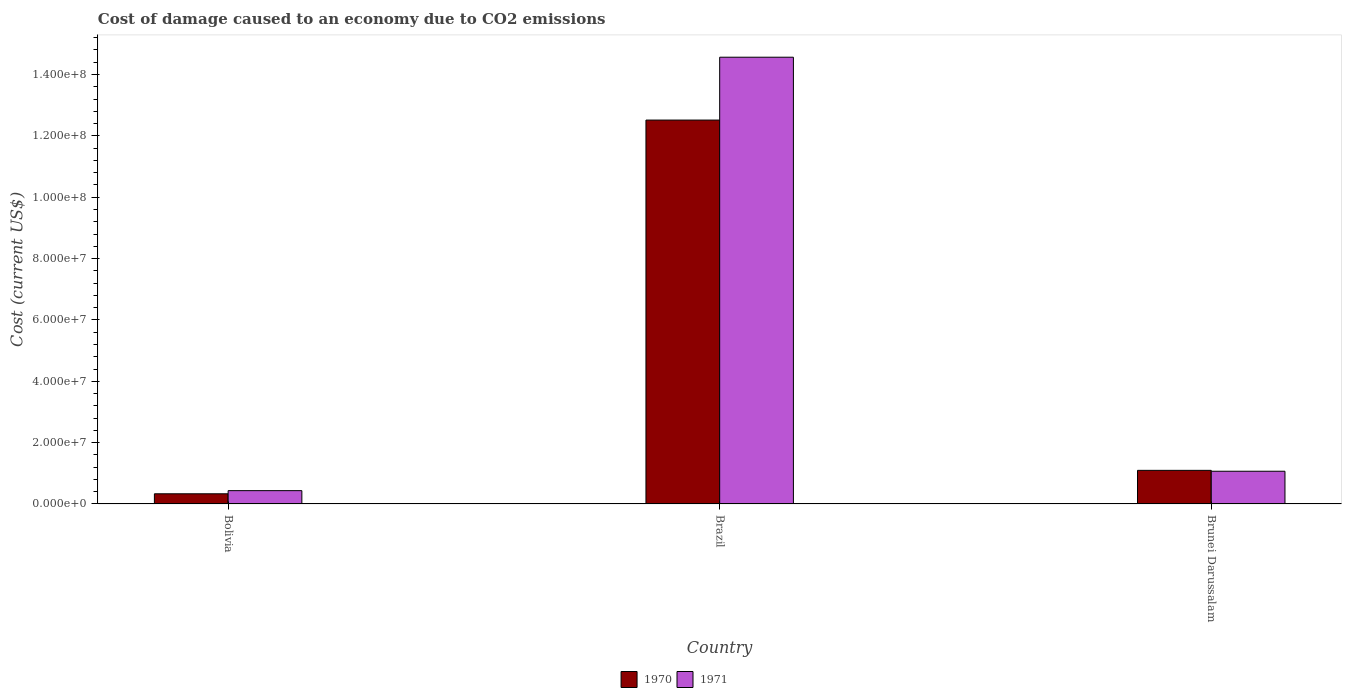Are the number of bars per tick equal to the number of legend labels?
Provide a short and direct response. Yes. How many bars are there on the 2nd tick from the left?
Give a very brief answer. 2. What is the label of the 3rd group of bars from the left?
Your answer should be compact. Brunei Darussalam. In how many cases, is the number of bars for a given country not equal to the number of legend labels?
Your answer should be very brief. 0. What is the cost of damage caused due to CO2 emissisons in 1971 in Brunei Darussalam?
Keep it short and to the point. 1.07e+07. Across all countries, what is the maximum cost of damage caused due to CO2 emissisons in 1971?
Provide a succinct answer. 1.46e+08. Across all countries, what is the minimum cost of damage caused due to CO2 emissisons in 1970?
Your response must be concise. 3.32e+06. In which country was the cost of damage caused due to CO2 emissisons in 1971 maximum?
Offer a very short reply. Brazil. In which country was the cost of damage caused due to CO2 emissisons in 1970 minimum?
Offer a terse response. Bolivia. What is the total cost of damage caused due to CO2 emissisons in 1970 in the graph?
Offer a very short reply. 1.39e+08. What is the difference between the cost of damage caused due to CO2 emissisons in 1971 in Bolivia and that in Brunei Darussalam?
Make the answer very short. -6.32e+06. What is the difference between the cost of damage caused due to CO2 emissisons in 1970 in Brunei Darussalam and the cost of damage caused due to CO2 emissisons in 1971 in Bolivia?
Make the answer very short. 6.61e+06. What is the average cost of damage caused due to CO2 emissisons in 1970 per country?
Your response must be concise. 4.65e+07. What is the difference between the cost of damage caused due to CO2 emissisons of/in 1970 and cost of damage caused due to CO2 emissisons of/in 1971 in Bolivia?
Give a very brief answer. -1.03e+06. What is the ratio of the cost of damage caused due to CO2 emissisons in 1971 in Bolivia to that in Brazil?
Your answer should be very brief. 0.03. Is the cost of damage caused due to CO2 emissisons in 1970 in Brazil less than that in Brunei Darussalam?
Your answer should be compact. No. Is the difference between the cost of damage caused due to CO2 emissisons in 1970 in Bolivia and Brazil greater than the difference between the cost of damage caused due to CO2 emissisons in 1971 in Bolivia and Brazil?
Ensure brevity in your answer.  Yes. What is the difference between the highest and the second highest cost of damage caused due to CO2 emissisons in 1970?
Your answer should be very brief. 1.22e+08. What is the difference between the highest and the lowest cost of damage caused due to CO2 emissisons in 1971?
Provide a succinct answer. 1.41e+08. In how many countries, is the cost of damage caused due to CO2 emissisons in 1970 greater than the average cost of damage caused due to CO2 emissisons in 1970 taken over all countries?
Provide a succinct answer. 1. What does the 2nd bar from the left in Brazil represents?
Make the answer very short. 1971. What does the 2nd bar from the right in Bolivia represents?
Provide a short and direct response. 1970. How many bars are there?
Ensure brevity in your answer.  6. Are all the bars in the graph horizontal?
Give a very brief answer. No. How many countries are there in the graph?
Provide a succinct answer. 3. Does the graph contain any zero values?
Give a very brief answer. No. Does the graph contain grids?
Your answer should be very brief. No. Where does the legend appear in the graph?
Offer a very short reply. Bottom center. What is the title of the graph?
Your answer should be compact. Cost of damage caused to an economy due to CO2 emissions. What is the label or title of the X-axis?
Offer a very short reply. Country. What is the label or title of the Y-axis?
Provide a succinct answer. Cost (current US$). What is the Cost (current US$) of 1970 in Bolivia?
Provide a succinct answer. 3.32e+06. What is the Cost (current US$) of 1971 in Bolivia?
Offer a very short reply. 4.35e+06. What is the Cost (current US$) in 1970 in Brazil?
Offer a terse response. 1.25e+08. What is the Cost (current US$) in 1971 in Brazil?
Your answer should be compact. 1.46e+08. What is the Cost (current US$) of 1970 in Brunei Darussalam?
Provide a short and direct response. 1.10e+07. What is the Cost (current US$) of 1971 in Brunei Darussalam?
Give a very brief answer. 1.07e+07. Across all countries, what is the maximum Cost (current US$) in 1970?
Provide a succinct answer. 1.25e+08. Across all countries, what is the maximum Cost (current US$) in 1971?
Offer a very short reply. 1.46e+08. Across all countries, what is the minimum Cost (current US$) of 1970?
Your response must be concise. 3.32e+06. Across all countries, what is the minimum Cost (current US$) in 1971?
Keep it short and to the point. 4.35e+06. What is the total Cost (current US$) in 1970 in the graph?
Make the answer very short. 1.39e+08. What is the total Cost (current US$) of 1971 in the graph?
Offer a very short reply. 1.61e+08. What is the difference between the Cost (current US$) of 1970 in Bolivia and that in Brazil?
Ensure brevity in your answer.  -1.22e+08. What is the difference between the Cost (current US$) of 1971 in Bolivia and that in Brazil?
Ensure brevity in your answer.  -1.41e+08. What is the difference between the Cost (current US$) of 1970 in Bolivia and that in Brunei Darussalam?
Your answer should be compact. -7.64e+06. What is the difference between the Cost (current US$) of 1971 in Bolivia and that in Brunei Darussalam?
Give a very brief answer. -6.32e+06. What is the difference between the Cost (current US$) in 1970 in Brazil and that in Brunei Darussalam?
Your answer should be very brief. 1.14e+08. What is the difference between the Cost (current US$) of 1971 in Brazil and that in Brunei Darussalam?
Ensure brevity in your answer.  1.35e+08. What is the difference between the Cost (current US$) of 1970 in Bolivia and the Cost (current US$) of 1971 in Brazil?
Your response must be concise. -1.42e+08. What is the difference between the Cost (current US$) of 1970 in Bolivia and the Cost (current US$) of 1971 in Brunei Darussalam?
Offer a terse response. -7.35e+06. What is the difference between the Cost (current US$) in 1970 in Brazil and the Cost (current US$) in 1971 in Brunei Darussalam?
Your answer should be compact. 1.14e+08. What is the average Cost (current US$) in 1970 per country?
Provide a succinct answer. 4.65e+07. What is the average Cost (current US$) of 1971 per country?
Offer a terse response. 5.36e+07. What is the difference between the Cost (current US$) in 1970 and Cost (current US$) in 1971 in Bolivia?
Offer a terse response. -1.03e+06. What is the difference between the Cost (current US$) in 1970 and Cost (current US$) in 1971 in Brazil?
Provide a short and direct response. -2.05e+07. What is the difference between the Cost (current US$) in 1970 and Cost (current US$) in 1971 in Brunei Darussalam?
Your answer should be compact. 2.92e+05. What is the ratio of the Cost (current US$) of 1970 in Bolivia to that in Brazil?
Offer a very short reply. 0.03. What is the ratio of the Cost (current US$) of 1971 in Bolivia to that in Brazil?
Your response must be concise. 0.03. What is the ratio of the Cost (current US$) of 1970 in Bolivia to that in Brunei Darussalam?
Provide a short and direct response. 0.3. What is the ratio of the Cost (current US$) in 1971 in Bolivia to that in Brunei Darussalam?
Your answer should be compact. 0.41. What is the ratio of the Cost (current US$) of 1970 in Brazil to that in Brunei Darussalam?
Offer a very short reply. 11.42. What is the ratio of the Cost (current US$) of 1971 in Brazil to that in Brunei Darussalam?
Give a very brief answer. 13.65. What is the difference between the highest and the second highest Cost (current US$) in 1970?
Offer a very short reply. 1.14e+08. What is the difference between the highest and the second highest Cost (current US$) in 1971?
Keep it short and to the point. 1.35e+08. What is the difference between the highest and the lowest Cost (current US$) in 1970?
Provide a short and direct response. 1.22e+08. What is the difference between the highest and the lowest Cost (current US$) of 1971?
Provide a short and direct response. 1.41e+08. 